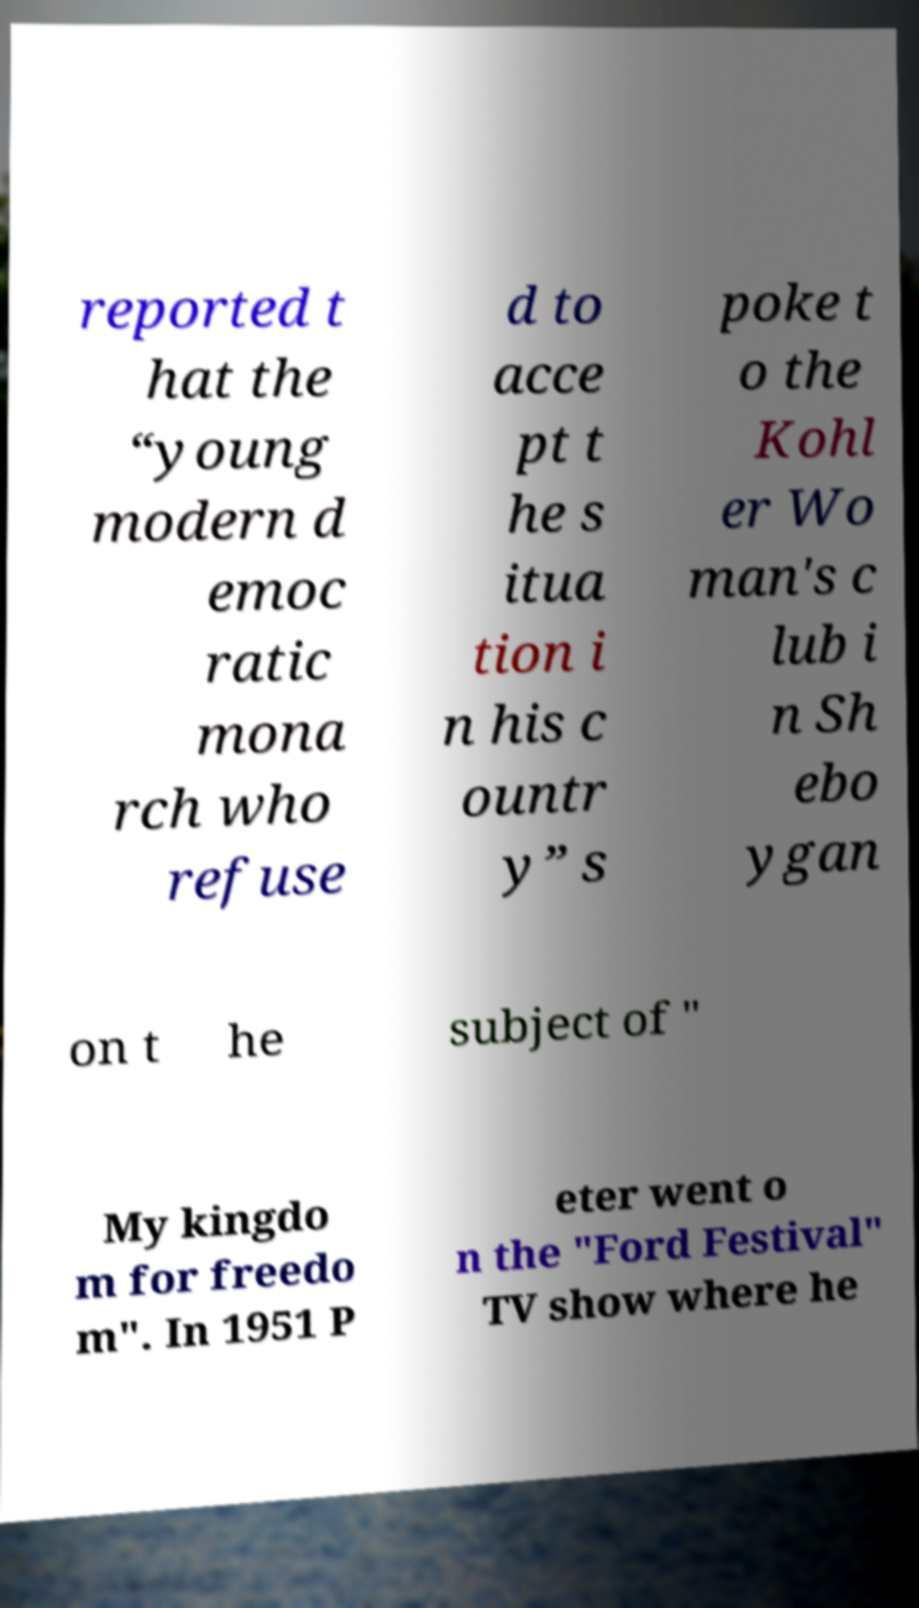There's text embedded in this image that I need extracted. Can you transcribe it verbatim? reported t hat the “young modern d emoc ratic mona rch who refuse d to acce pt t he s itua tion i n his c ountr y” s poke t o the Kohl er Wo man's c lub i n Sh ebo ygan on t he subject of " My kingdo m for freedo m". In 1951 P eter went o n the "Ford Festival" TV show where he 